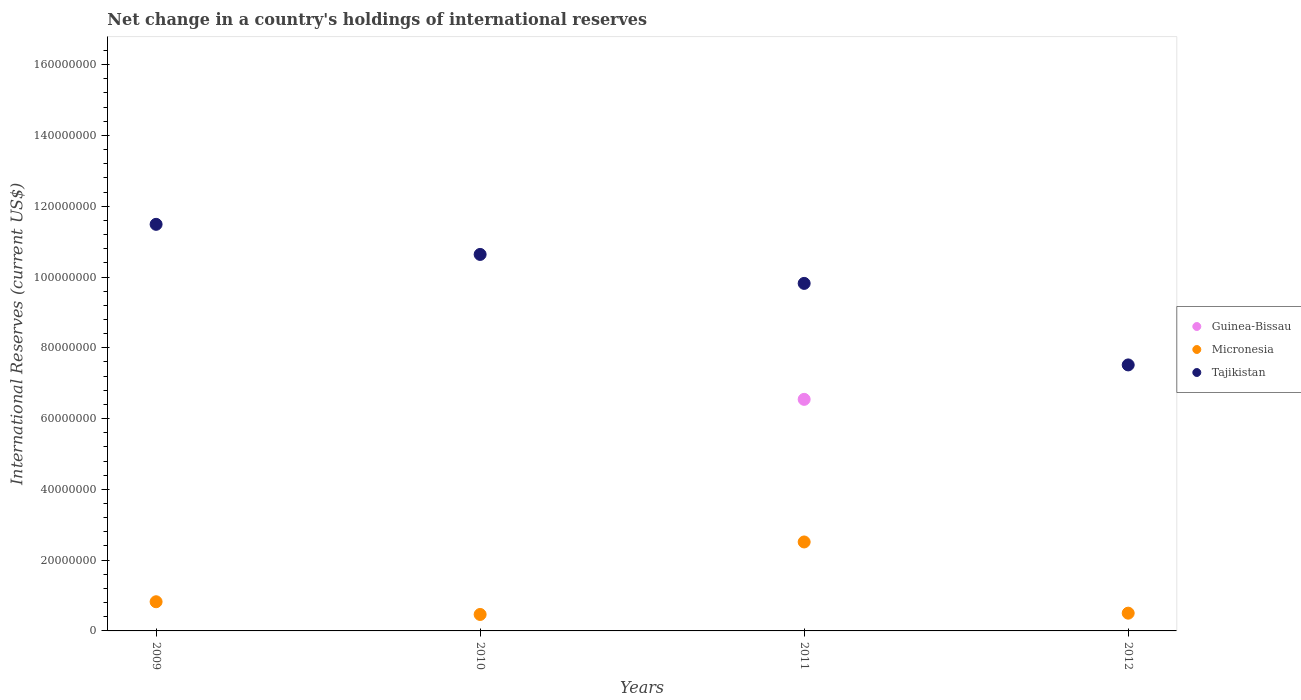What is the international reserves in Guinea-Bissau in 2009?
Offer a very short reply. 0. Across all years, what is the maximum international reserves in Tajikistan?
Keep it short and to the point. 1.15e+08. Across all years, what is the minimum international reserves in Guinea-Bissau?
Ensure brevity in your answer.  0. In which year was the international reserves in Tajikistan maximum?
Your answer should be very brief. 2009. What is the total international reserves in Guinea-Bissau in the graph?
Make the answer very short. 6.54e+07. What is the difference between the international reserves in Micronesia in 2011 and that in 2012?
Provide a short and direct response. 2.01e+07. What is the difference between the international reserves in Guinea-Bissau in 2009 and the international reserves in Micronesia in 2010?
Provide a succinct answer. -4.65e+06. What is the average international reserves in Micronesia per year?
Provide a succinct answer. 1.08e+07. In the year 2011, what is the difference between the international reserves in Guinea-Bissau and international reserves in Micronesia?
Your answer should be very brief. 4.03e+07. What is the ratio of the international reserves in Micronesia in 2009 to that in 2010?
Provide a succinct answer. 1.77. What is the difference between the highest and the second highest international reserves in Micronesia?
Your answer should be very brief. 1.69e+07. What is the difference between the highest and the lowest international reserves in Tajikistan?
Offer a terse response. 3.97e+07. In how many years, is the international reserves in Guinea-Bissau greater than the average international reserves in Guinea-Bissau taken over all years?
Your answer should be compact. 1. How many dotlines are there?
Keep it short and to the point. 3. Does the graph contain any zero values?
Offer a very short reply. Yes. Does the graph contain grids?
Make the answer very short. No. How many legend labels are there?
Provide a succinct answer. 3. How are the legend labels stacked?
Your answer should be compact. Vertical. What is the title of the graph?
Your answer should be very brief. Net change in a country's holdings of international reserves. Does "St. Martin (French part)" appear as one of the legend labels in the graph?
Your answer should be compact. No. What is the label or title of the Y-axis?
Your answer should be compact. International Reserves (current US$). What is the International Reserves (current US$) in Guinea-Bissau in 2009?
Your response must be concise. 0. What is the International Reserves (current US$) of Micronesia in 2009?
Keep it short and to the point. 8.24e+06. What is the International Reserves (current US$) of Tajikistan in 2009?
Ensure brevity in your answer.  1.15e+08. What is the International Reserves (current US$) in Micronesia in 2010?
Your response must be concise. 4.65e+06. What is the International Reserves (current US$) in Tajikistan in 2010?
Offer a terse response. 1.06e+08. What is the International Reserves (current US$) of Guinea-Bissau in 2011?
Ensure brevity in your answer.  6.54e+07. What is the International Reserves (current US$) in Micronesia in 2011?
Provide a succinct answer. 2.51e+07. What is the International Reserves (current US$) of Tajikistan in 2011?
Your answer should be very brief. 9.82e+07. What is the International Reserves (current US$) in Guinea-Bissau in 2012?
Give a very brief answer. 0. What is the International Reserves (current US$) in Micronesia in 2012?
Your answer should be compact. 5.02e+06. What is the International Reserves (current US$) of Tajikistan in 2012?
Your response must be concise. 7.52e+07. Across all years, what is the maximum International Reserves (current US$) of Guinea-Bissau?
Make the answer very short. 6.54e+07. Across all years, what is the maximum International Reserves (current US$) of Micronesia?
Ensure brevity in your answer.  2.51e+07. Across all years, what is the maximum International Reserves (current US$) of Tajikistan?
Keep it short and to the point. 1.15e+08. Across all years, what is the minimum International Reserves (current US$) in Micronesia?
Offer a very short reply. 4.65e+06. Across all years, what is the minimum International Reserves (current US$) in Tajikistan?
Provide a short and direct response. 7.52e+07. What is the total International Reserves (current US$) in Guinea-Bissau in the graph?
Offer a very short reply. 6.54e+07. What is the total International Reserves (current US$) in Micronesia in the graph?
Your answer should be compact. 4.30e+07. What is the total International Reserves (current US$) of Tajikistan in the graph?
Ensure brevity in your answer.  3.95e+08. What is the difference between the International Reserves (current US$) in Micronesia in 2009 and that in 2010?
Make the answer very short. 3.59e+06. What is the difference between the International Reserves (current US$) in Tajikistan in 2009 and that in 2010?
Provide a succinct answer. 8.50e+06. What is the difference between the International Reserves (current US$) in Micronesia in 2009 and that in 2011?
Give a very brief answer. -1.69e+07. What is the difference between the International Reserves (current US$) in Tajikistan in 2009 and that in 2011?
Your answer should be compact. 1.67e+07. What is the difference between the International Reserves (current US$) in Micronesia in 2009 and that in 2012?
Your answer should be compact. 3.22e+06. What is the difference between the International Reserves (current US$) in Tajikistan in 2009 and that in 2012?
Ensure brevity in your answer.  3.97e+07. What is the difference between the International Reserves (current US$) in Micronesia in 2010 and that in 2011?
Keep it short and to the point. -2.05e+07. What is the difference between the International Reserves (current US$) of Tajikistan in 2010 and that in 2011?
Ensure brevity in your answer.  8.18e+06. What is the difference between the International Reserves (current US$) in Micronesia in 2010 and that in 2012?
Ensure brevity in your answer.  -3.69e+05. What is the difference between the International Reserves (current US$) of Tajikistan in 2010 and that in 2012?
Offer a very short reply. 3.12e+07. What is the difference between the International Reserves (current US$) in Micronesia in 2011 and that in 2012?
Offer a very short reply. 2.01e+07. What is the difference between the International Reserves (current US$) of Tajikistan in 2011 and that in 2012?
Your answer should be compact. 2.30e+07. What is the difference between the International Reserves (current US$) in Micronesia in 2009 and the International Reserves (current US$) in Tajikistan in 2010?
Your answer should be compact. -9.81e+07. What is the difference between the International Reserves (current US$) in Micronesia in 2009 and the International Reserves (current US$) in Tajikistan in 2011?
Give a very brief answer. -9.00e+07. What is the difference between the International Reserves (current US$) of Micronesia in 2009 and the International Reserves (current US$) of Tajikistan in 2012?
Keep it short and to the point. -6.69e+07. What is the difference between the International Reserves (current US$) of Micronesia in 2010 and the International Reserves (current US$) of Tajikistan in 2011?
Ensure brevity in your answer.  -9.35e+07. What is the difference between the International Reserves (current US$) of Micronesia in 2010 and the International Reserves (current US$) of Tajikistan in 2012?
Keep it short and to the point. -7.05e+07. What is the difference between the International Reserves (current US$) in Guinea-Bissau in 2011 and the International Reserves (current US$) in Micronesia in 2012?
Ensure brevity in your answer.  6.04e+07. What is the difference between the International Reserves (current US$) in Guinea-Bissau in 2011 and the International Reserves (current US$) in Tajikistan in 2012?
Make the answer very short. -9.73e+06. What is the difference between the International Reserves (current US$) in Micronesia in 2011 and the International Reserves (current US$) in Tajikistan in 2012?
Keep it short and to the point. -5.00e+07. What is the average International Reserves (current US$) in Guinea-Bissau per year?
Make the answer very short. 1.64e+07. What is the average International Reserves (current US$) in Micronesia per year?
Keep it short and to the point. 1.08e+07. What is the average International Reserves (current US$) in Tajikistan per year?
Give a very brief answer. 9.87e+07. In the year 2009, what is the difference between the International Reserves (current US$) in Micronesia and International Reserves (current US$) in Tajikistan?
Keep it short and to the point. -1.07e+08. In the year 2010, what is the difference between the International Reserves (current US$) of Micronesia and International Reserves (current US$) of Tajikistan?
Your answer should be very brief. -1.02e+08. In the year 2011, what is the difference between the International Reserves (current US$) of Guinea-Bissau and International Reserves (current US$) of Micronesia?
Your answer should be very brief. 4.03e+07. In the year 2011, what is the difference between the International Reserves (current US$) of Guinea-Bissau and International Reserves (current US$) of Tajikistan?
Keep it short and to the point. -3.28e+07. In the year 2011, what is the difference between the International Reserves (current US$) of Micronesia and International Reserves (current US$) of Tajikistan?
Offer a terse response. -7.31e+07. In the year 2012, what is the difference between the International Reserves (current US$) of Micronesia and International Reserves (current US$) of Tajikistan?
Your response must be concise. -7.01e+07. What is the ratio of the International Reserves (current US$) of Micronesia in 2009 to that in 2010?
Provide a succinct answer. 1.77. What is the ratio of the International Reserves (current US$) of Tajikistan in 2009 to that in 2010?
Give a very brief answer. 1.08. What is the ratio of the International Reserves (current US$) of Micronesia in 2009 to that in 2011?
Give a very brief answer. 0.33. What is the ratio of the International Reserves (current US$) of Tajikistan in 2009 to that in 2011?
Your answer should be compact. 1.17. What is the ratio of the International Reserves (current US$) of Micronesia in 2009 to that in 2012?
Your answer should be very brief. 1.64. What is the ratio of the International Reserves (current US$) in Tajikistan in 2009 to that in 2012?
Keep it short and to the point. 1.53. What is the ratio of the International Reserves (current US$) in Micronesia in 2010 to that in 2011?
Give a very brief answer. 0.18. What is the ratio of the International Reserves (current US$) in Tajikistan in 2010 to that in 2011?
Your answer should be very brief. 1.08. What is the ratio of the International Reserves (current US$) of Micronesia in 2010 to that in 2012?
Offer a terse response. 0.93. What is the ratio of the International Reserves (current US$) of Tajikistan in 2010 to that in 2012?
Keep it short and to the point. 1.42. What is the ratio of the International Reserves (current US$) in Micronesia in 2011 to that in 2012?
Give a very brief answer. 5.01. What is the ratio of the International Reserves (current US$) of Tajikistan in 2011 to that in 2012?
Your answer should be very brief. 1.31. What is the difference between the highest and the second highest International Reserves (current US$) in Micronesia?
Ensure brevity in your answer.  1.69e+07. What is the difference between the highest and the second highest International Reserves (current US$) of Tajikistan?
Provide a succinct answer. 8.50e+06. What is the difference between the highest and the lowest International Reserves (current US$) of Guinea-Bissau?
Ensure brevity in your answer.  6.54e+07. What is the difference between the highest and the lowest International Reserves (current US$) in Micronesia?
Make the answer very short. 2.05e+07. What is the difference between the highest and the lowest International Reserves (current US$) in Tajikistan?
Provide a succinct answer. 3.97e+07. 